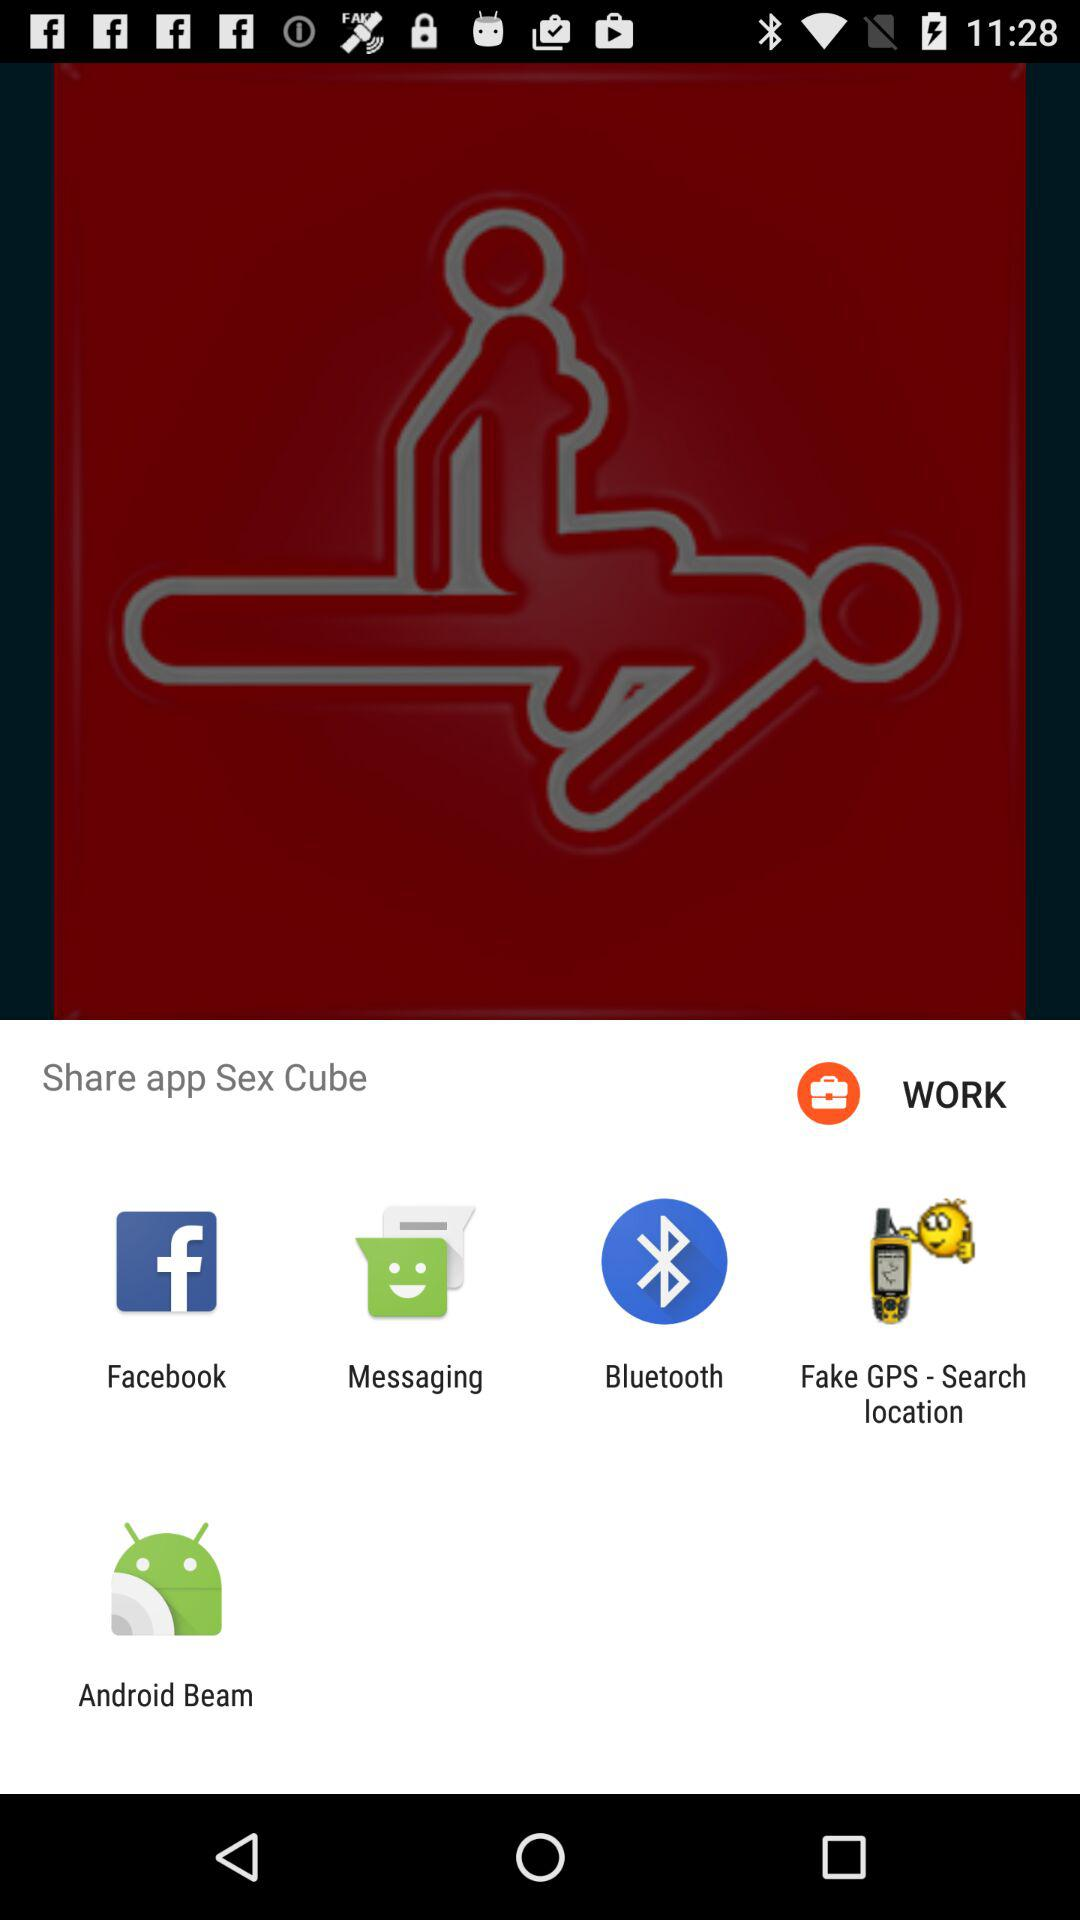How many Sharing options are available?
When the provided information is insufficient, respond with <no answer>. <no answer> 